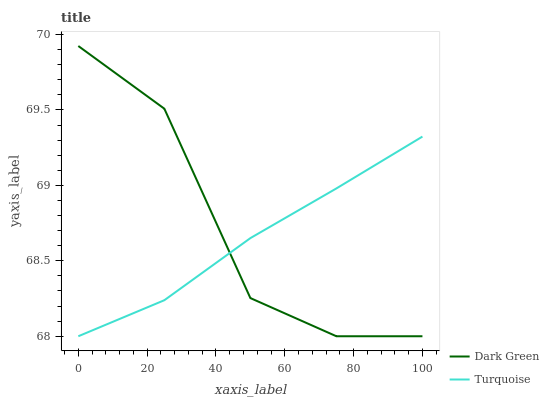Does Turquoise have the minimum area under the curve?
Answer yes or no. Yes. Does Dark Green have the maximum area under the curve?
Answer yes or no. Yes. Does Dark Green have the minimum area under the curve?
Answer yes or no. No. Is Turquoise the smoothest?
Answer yes or no. Yes. Is Dark Green the roughest?
Answer yes or no. Yes. Is Dark Green the smoothest?
Answer yes or no. No. Does Turquoise have the lowest value?
Answer yes or no. Yes. Does Dark Green have the highest value?
Answer yes or no. Yes. Does Dark Green intersect Turquoise?
Answer yes or no. Yes. Is Dark Green less than Turquoise?
Answer yes or no. No. Is Dark Green greater than Turquoise?
Answer yes or no. No. 